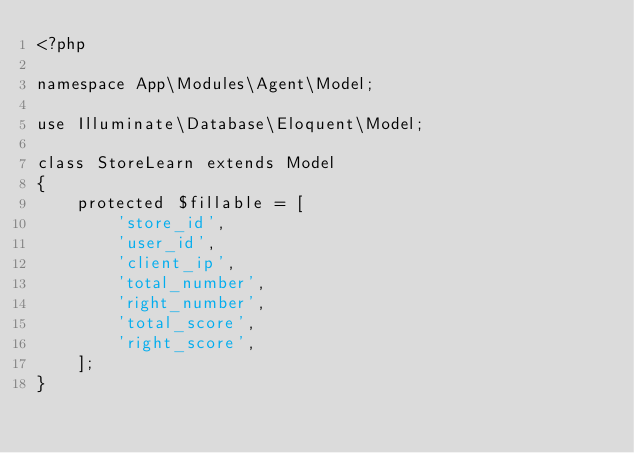<code> <loc_0><loc_0><loc_500><loc_500><_PHP_><?php

namespace App\Modules\Agent\Model;

use Illuminate\Database\Eloquent\Model;

class StoreLearn extends Model
{
    protected $fillable = [
        'store_id',
        'user_id',
        'client_ip',
        'total_number',
        'right_number',
        'total_score',
        'right_score',
    ];
}
</code> 